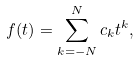<formula> <loc_0><loc_0><loc_500><loc_500>f ( t ) = \sum _ { k = - N } ^ { N } c _ { k } t ^ { k } ,</formula> 